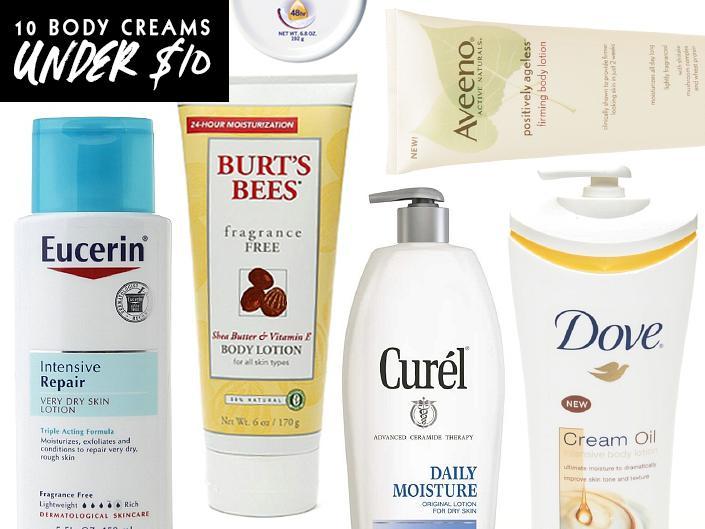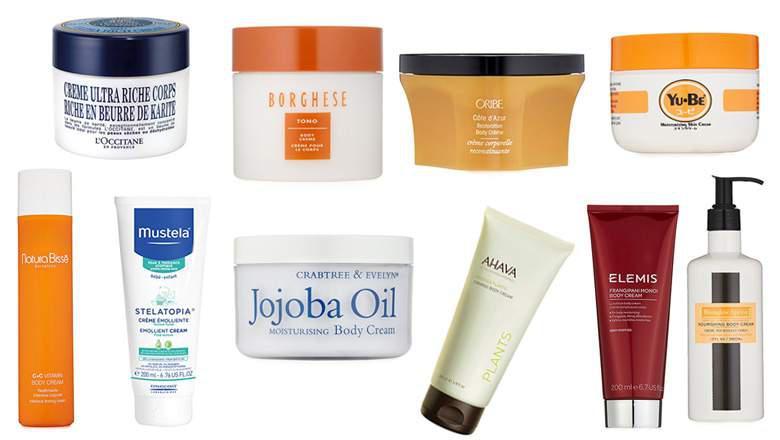The first image is the image on the left, the second image is the image on the right. Examine the images to the left and right. Is the description "There are more items in the right image than in the left image." accurate? Answer yes or no. Yes. 